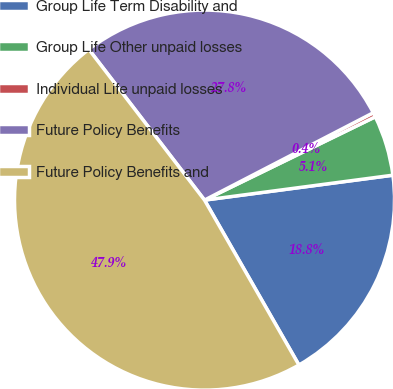Convert chart to OTSL. <chart><loc_0><loc_0><loc_500><loc_500><pie_chart><fcel>Group Life Term Disability and<fcel>Group Life Other unpaid losses<fcel>Individual Life unpaid losses<fcel>Future Policy Benefits<fcel>Future Policy Benefits and<nl><fcel>18.82%<fcel>5.13%<fcel>0.38%<fcel>27.82%<fcel>47.86%<nl></chart> 